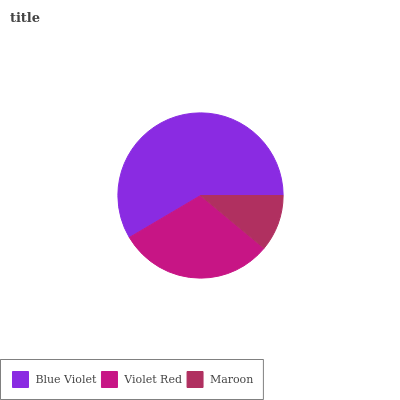Is Maroon the minimum?
Answer yes or no. Yes. Is Blue Violet the maximum?
Answer yes or no. Yes. Is Violet Red the minimum?
Answer yes or no. No. Is Violet Red the maximum?
Answer yes or no. No. Is Blue Violet greater than Violet Red?
Answer yes or no. Yes. Is Violet Red less than Blue Violet?
Answer yes or no. Yes. Is Violet Red greater than Blue Violet?
Answer yes or no. No. Is Blue Violet less than Violet Red?
Answer yes or no. No. Is Violet Red the high median?
Answer yes or no. Yes. Is Violet Red the low median?
Answer yes or no. Yes. Is Maroon the high median?
Answer yes or no. No. Is Blue Violet the low median?
Answer yes or no. No. 